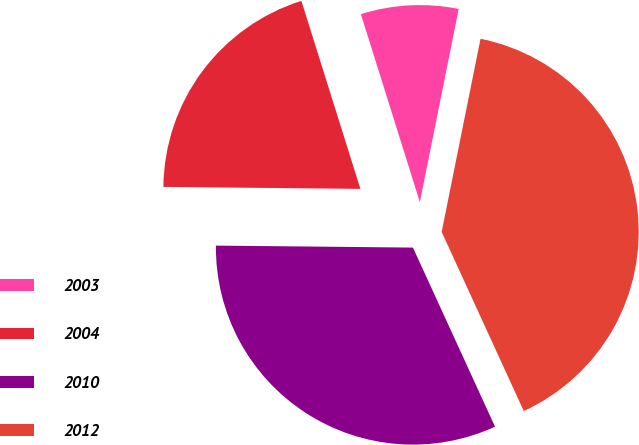<chart> <loc_0><loc_0><loc_500><loc_500><pie_chart><fcel>2003<fcel>2004<fcel>2010<fcel>2012<nl><fcel>8.0%<fcel>20.0%<fcel>32.0%<fcel>40.0%<nl></chart> 